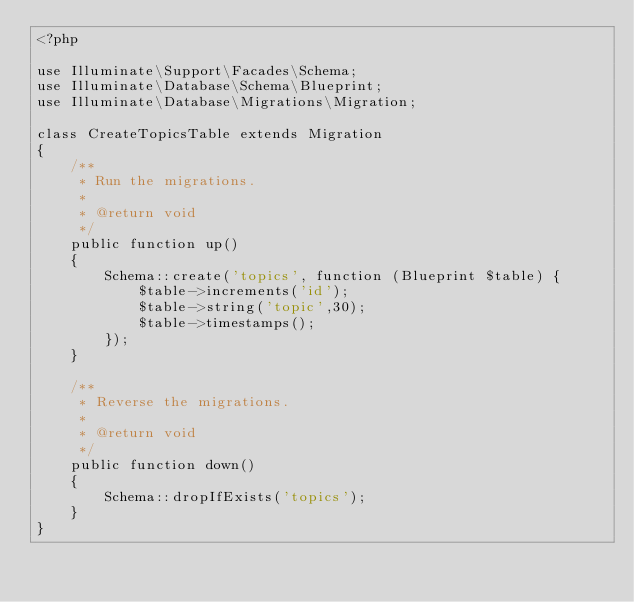Convert code to text. <code><loc_0><loc_0><loc_500><loc_500><_PHP_><?php

use Illuminate\Support\Facades\Schema;
use Illuminate\Database\Schema\Blueprint;
use Illuminate\Database\Migrations\Migration;

class CreateTopicsTable extends Migration
{
    /**
     * Run the migrations.
     *
     * @return void
     */
    public function up()
    {
        Schema::create('topics', function (Blueprint $table) {
            $table->increments('id');
            $table->string('topic',30);
            $table->timestamps();
        });
    }

    /**
     * Reverse the migrations.
     *
     * @return void
     */
    public function down()
    {
        Schema::dropIfExists('topics');
    }
}
</code> 